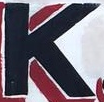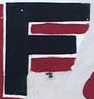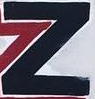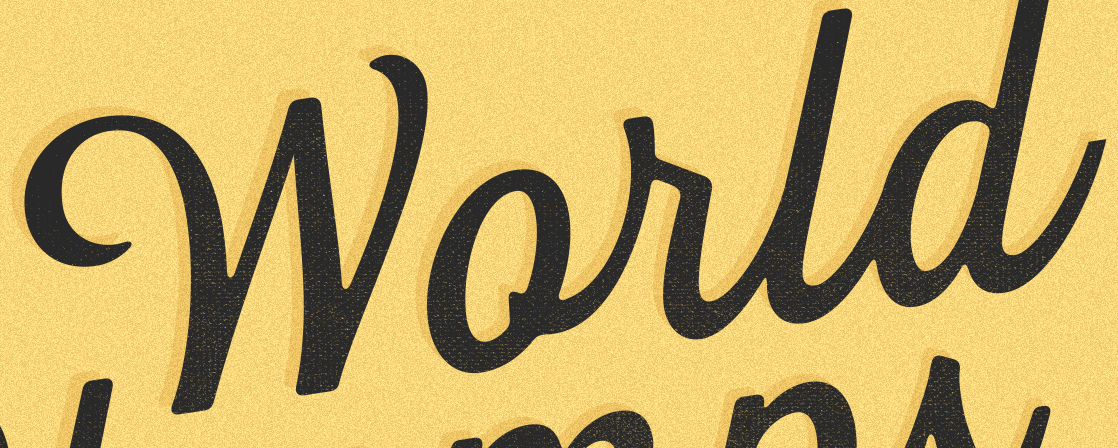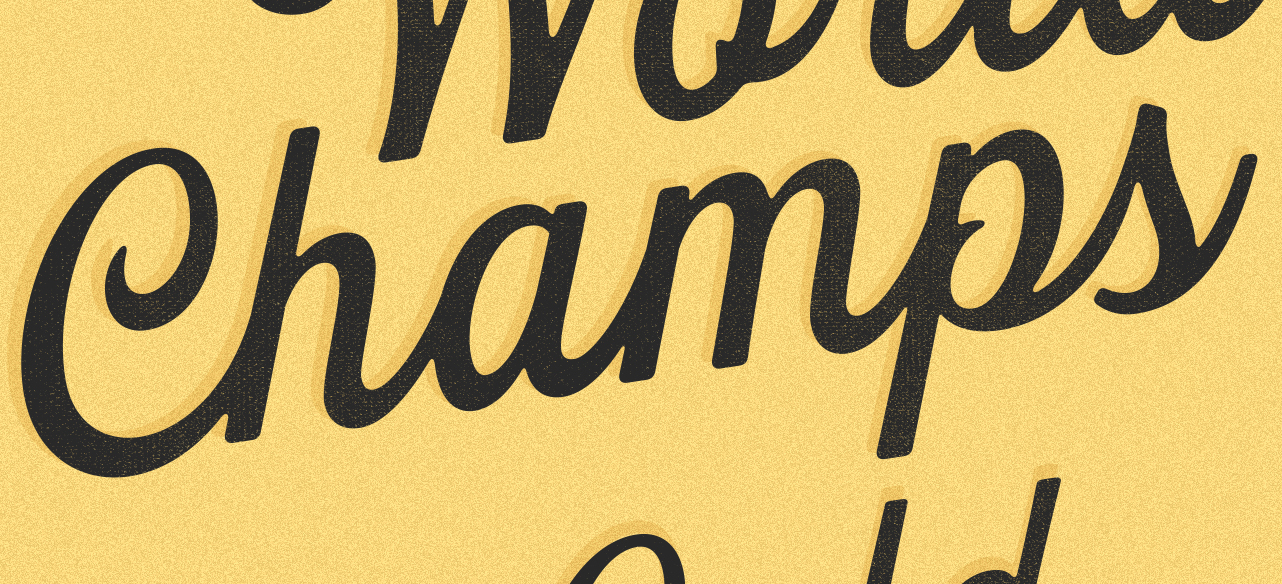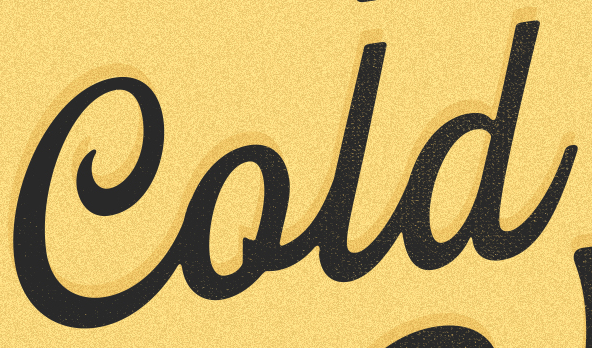Transcribe the words shown in these images in order, separated by a semicolon. K; F; Z; World; Champs; Cold 